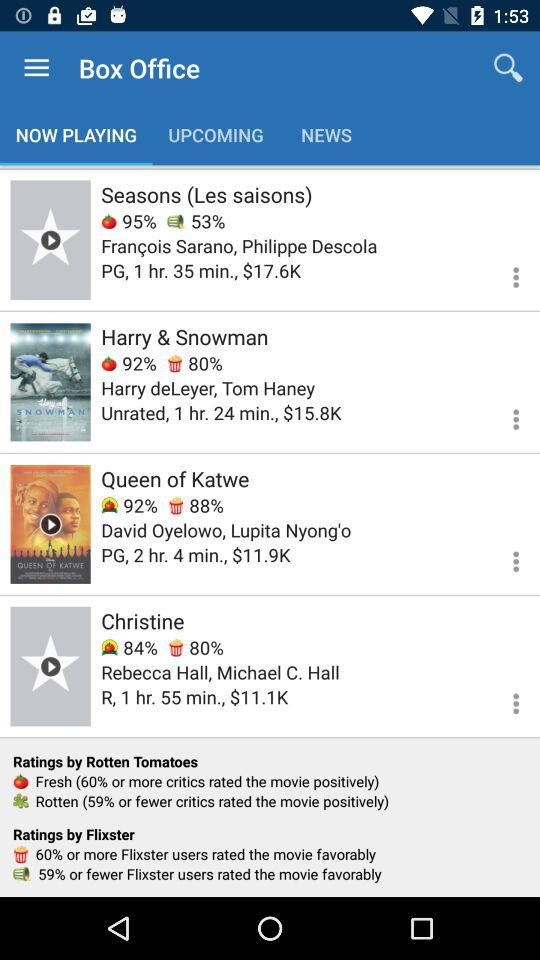How many movies have a rating of less than 80% on Flixster?
Answer the question using a single word or phrase. 1 